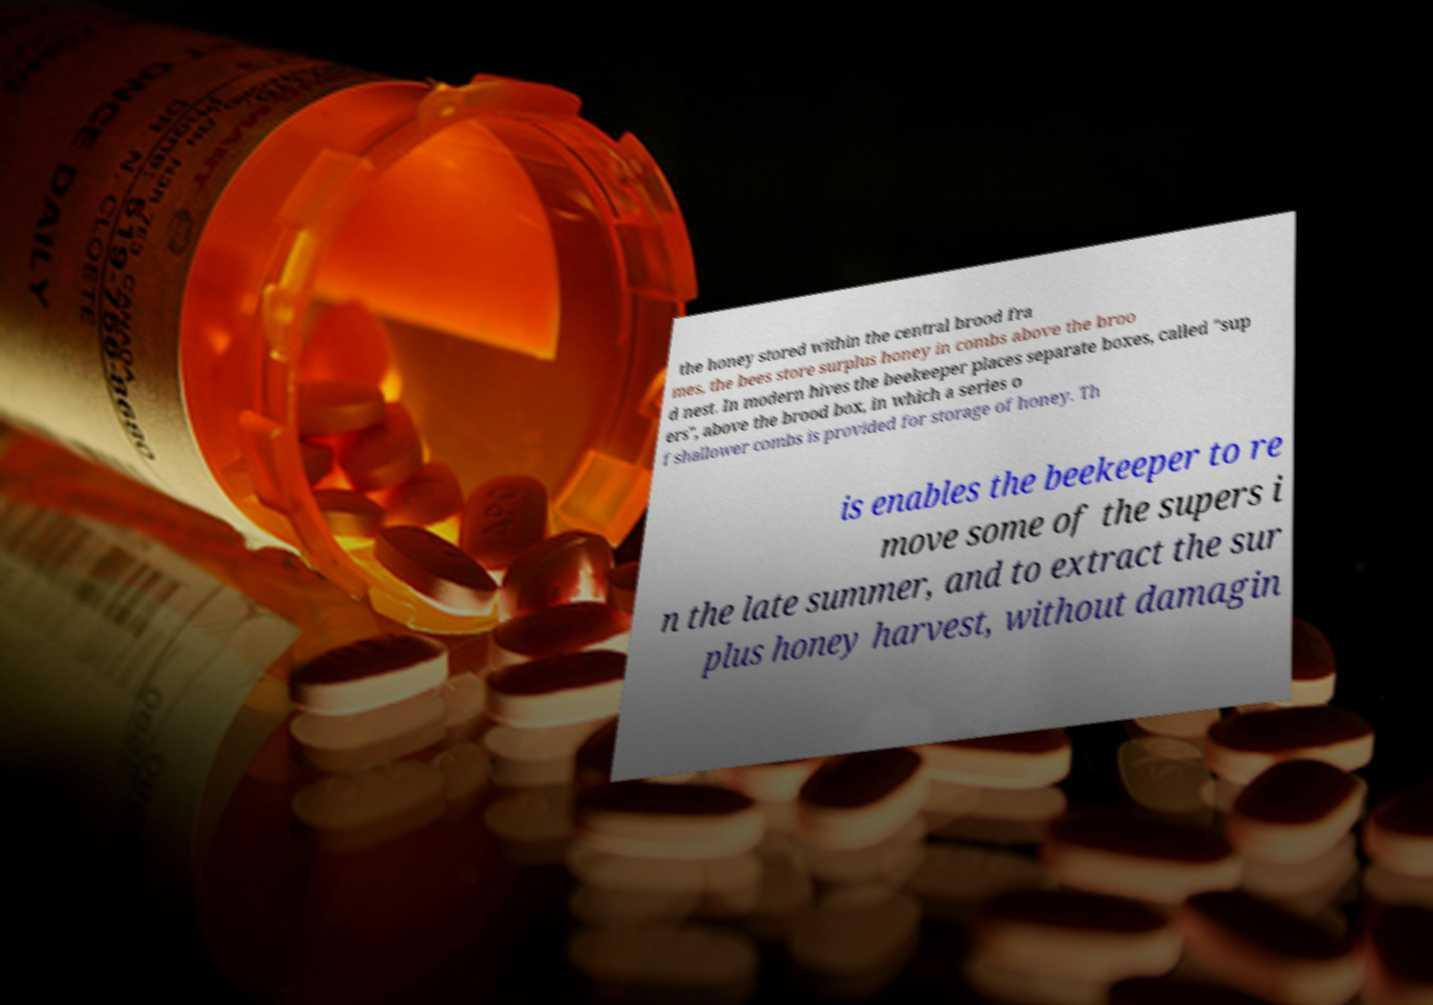Could you assist in decoding the text presented in this image and type it out clearly? the honey stored within the central brood fra mes, the bees store surplus honey in combs above the broo d nest. In modern hives the beekeeper places separate boxes, called "sup ers", above the brood box, in which a series o f shallower combs is provided for storage of honey. Th is enables the beekeeper to re move some of the supers i n the late summer, and to extract the sur plus honey harvest, without damagin 